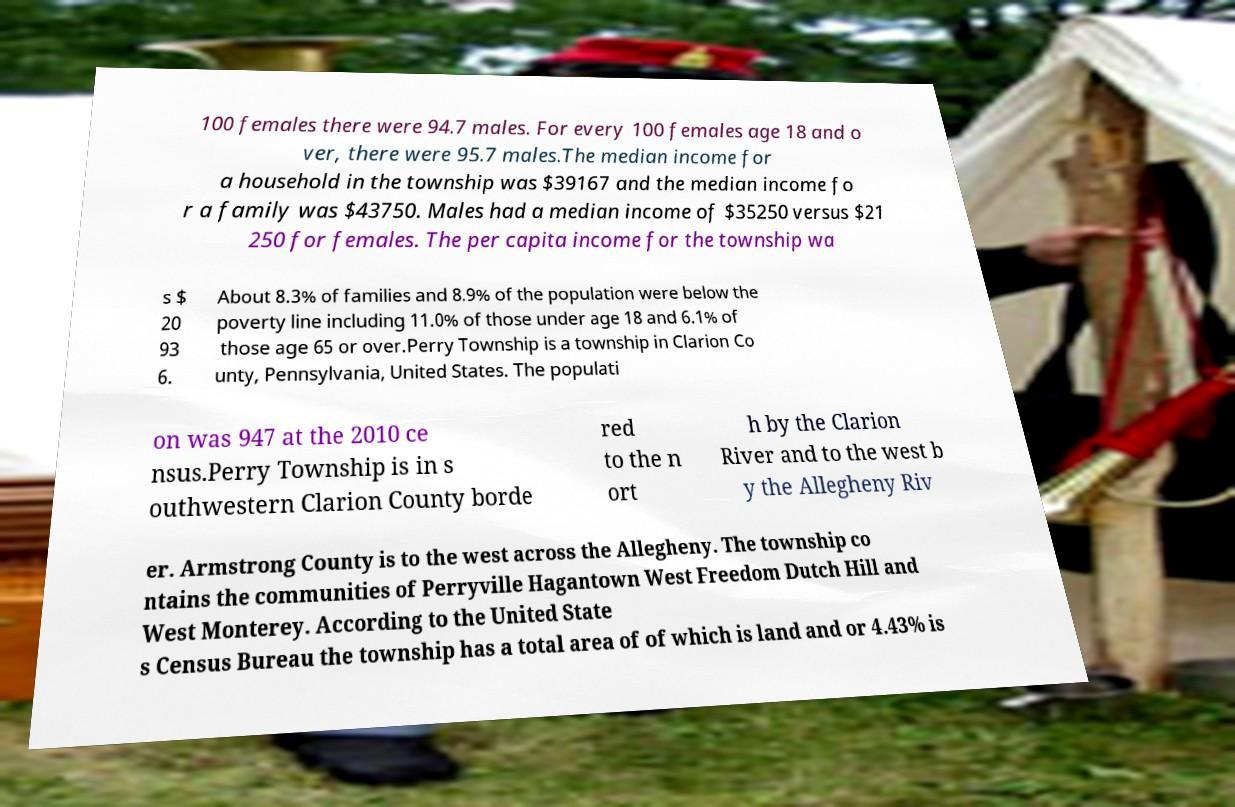I need the written content from this picture converted into text. Can you do that? 100 females there were 94.7 males. For every 100 females age 18 and o ver, there were 95.7 males.The median income for a household in the township was $39167 and the median income fo r a family was $43750. Males had a median income of $35250 versus $21 250 for females. The per capita income for the township wa s $ 20 93 6. About 8.3% of families and 8.9% of the population were below the poverty line including 11.0% of those under age 18 and 6.1% of those age 65 or over.Perry Township is a township in Clarion Co unty, Pennsylvania, United States. The populati on was 947 at the 2010 ce nsus.Perry Township is in s outhwestern Clarion County borde red to the n ort h by the Clarion River and to the west b y the Allegheny Riv er. Armstrong County is to the west across the Allegheny. The township co ntains the communities of Perryville Hagantown West Freedom Dutch Hill and West Monterey. According to the United State s Census Bureau the township has a total area of of which is land and or 4.43% is 